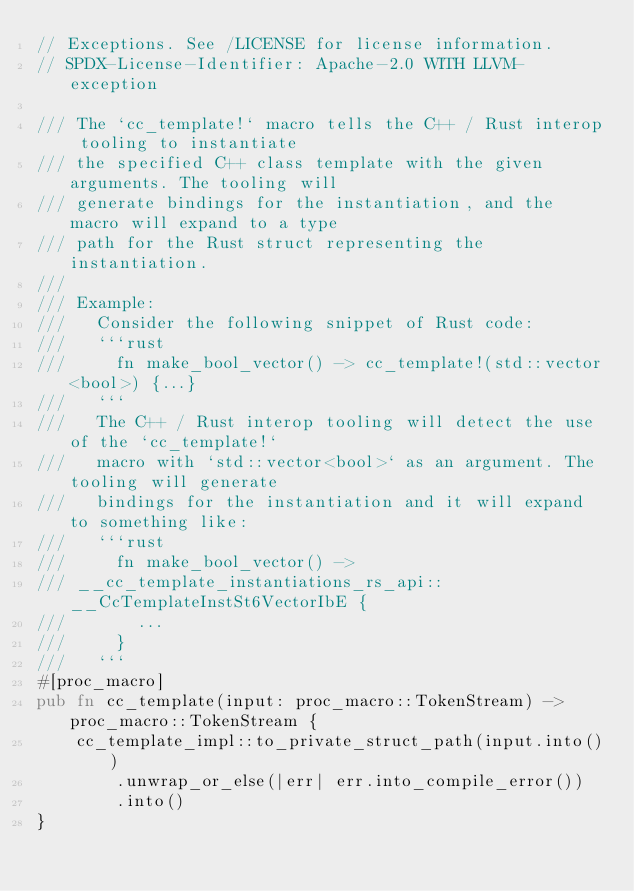<code> <loc_0><loc_0><loc_500><loc_500><_Rust_>// Exceptions. See /LICENSE for license information.
// SPDX-License-Identifier: Apache-2.0 WITH LLVM-exception

/// The `cc_template!` macro tells the C++ / Rust interop tooling to instantiate
/// the specified C++ class template with the given arguments. The tooling will
/// generate bindings for the instantiation, and the macro will expand to a type
/// path for the Rust struct representing the instantiation.
///
/// Example:
///   Consider the following snippet of Rust code:
///   ```rust
///     fn make_bool_vector() -> cc_template!(std::vector<bool>) {...}
///   ```
///   The C++ / Rust interop tooling will detect the use of the `cc_template!`
///   macro with `std::vector<bool>` as an argument. The tooling will generate
///   bindings for the instantiation and it will expand to something like:
///   ```rust
///     fn make_bool_vector() ->
/// __cc_template_instantiations_rs_api::__CcTemplateInstSt6VectorIbE {
///       ...
///     }
///   ```
#[proc_macro]
pub fn cc_template(input: proc_macro::TokenStream) -> proc_macro::TokenStream {
    cc_template_impl::to_private_struct_path(input.into())
        .unwrap_or_else(|err| err.into_compile_error())
        .into()
}
</code> 